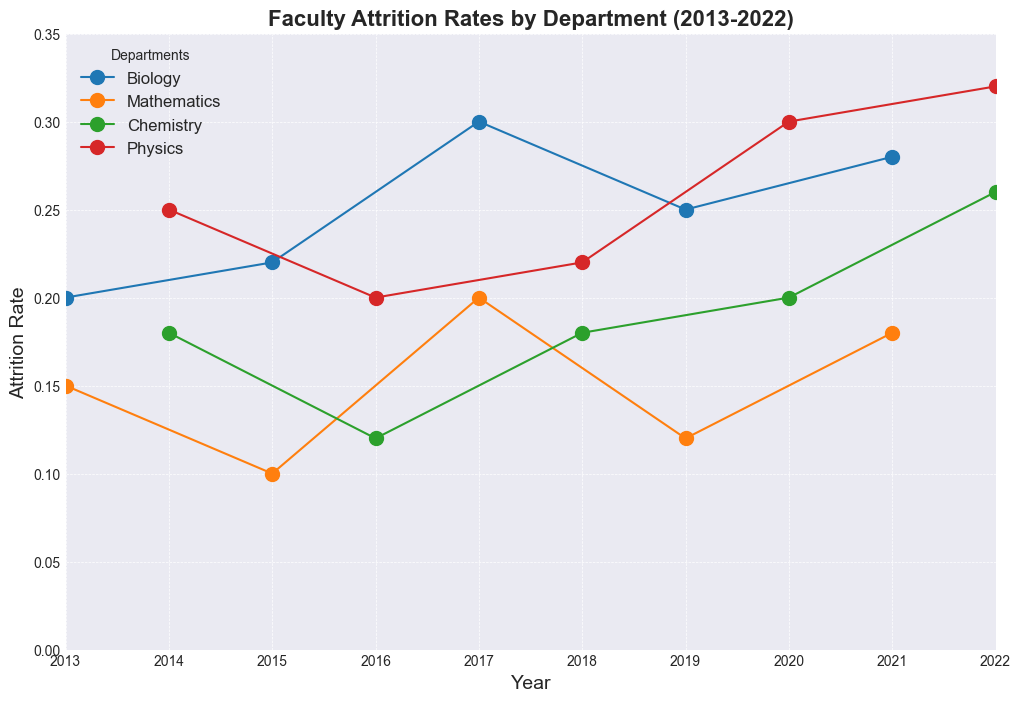what's the average attrition rate for the Biology department from 2013 to 2022? To find the average attrition rate for the Biology department from 2013 to 2022, sum up the attrition rates for Biology (0.2, 0.22, 0.3, 0.25, 0.28) and then divide by the number of years, which is 5. So, (0.2 + 0.22 + 0.3 + 0.25 + 0.28) / 5 = 1.25 / 5 = 0.25
Answer: 0.25 Which department had the highest attrition rate, and in which year did it occur? By examining the plot, it is clear that the highest attrition rate is for the Physics department in 2022, with an attrition rate of 0.32.
Answer: Physics in 2022 How does the average attrition rate of the Chemistry department compare to that of the Mathematics department over the decade? Calculate the average attrition rate for Chemistry (0.18, 0.12, 0.18, 0.2, 0.26) and Mathematics (0.15, 0.1, 0.2, 0.12, 0.18). For Chemistry: (0.18 + 0.12 + 0.18 + 0.2 + 0.26) / 5 = 0.19. For Mathematics: (0.15 + 0.1 + 0.2 + 0.12 + 0.18) / 5 = 0.15. Comparing both, Chemistry has a higher average attrition rate of 0.19 compared to 0.15 for Mathematics.
Answer: Chemistry has a higher average Which year shows the greatest difference between the highest and lowest attrition rates across departments? Reviewing the plot, 2022 has the greatest difference between the highest (0.32 in Physics) and lowest attrition rates (0.26 in Chemistry). The difference is 0.32 - 0.26 = 0.06.
Answer: 2022 What trend can be observed in the Physics department's attrition rate from 2013 to 2022? The Physics department's attrition rate shows an increasing trend over the decade. Starting from 0.25 in 2014, it dipped to 0.2 in 2016 but steadily rose to 0.32 by 2022.
Answer: Increasing trend Is there any department whose attrition rate consistently increased over the years? If so, name it. By examining the plot, the Chemistry department's attrition rate shows a consistent increase over the years, starting at 0.18 in 2014 and increasing gradually to 0.26 in 2022, except for a slight dip in 2016.
Answer: Chemistry Between 2013 and 2022, what is the general trend observed for the Mathematics department’s attrition rate? The Mathematics department showed a varying trend with an initial decrease from 0.15 in 2013 to 0.1 in 2015, then an increase to 0.2 in 2017, followed by another drop to 0.12 in 2019, and finally increased to 0.18 in 2021. Despite some fluctuations, the attrition rate has a general upward trend in the later years.
Answer: Varying with a late upward trend Which department experienced the largest single-year increase in attrition rate, and by how much? The Biology department experienced the largest single-year increase in attrition rate from 2016 to 2017, increasing from 0.22 to 0.3. The increase is 0.3 - 0.22 = 0.08.
Answer: Biology by 0.08 How does the variability in attrition rates in the Chemistry department compare to that in the Biology department? Evaluating the plot, Chemistry's rates range from 0.12 to 0.26, showing less variability. Biology's range from 0.2 to 0.3 indicates higher variability.
Answer: Biology shows higher variability 